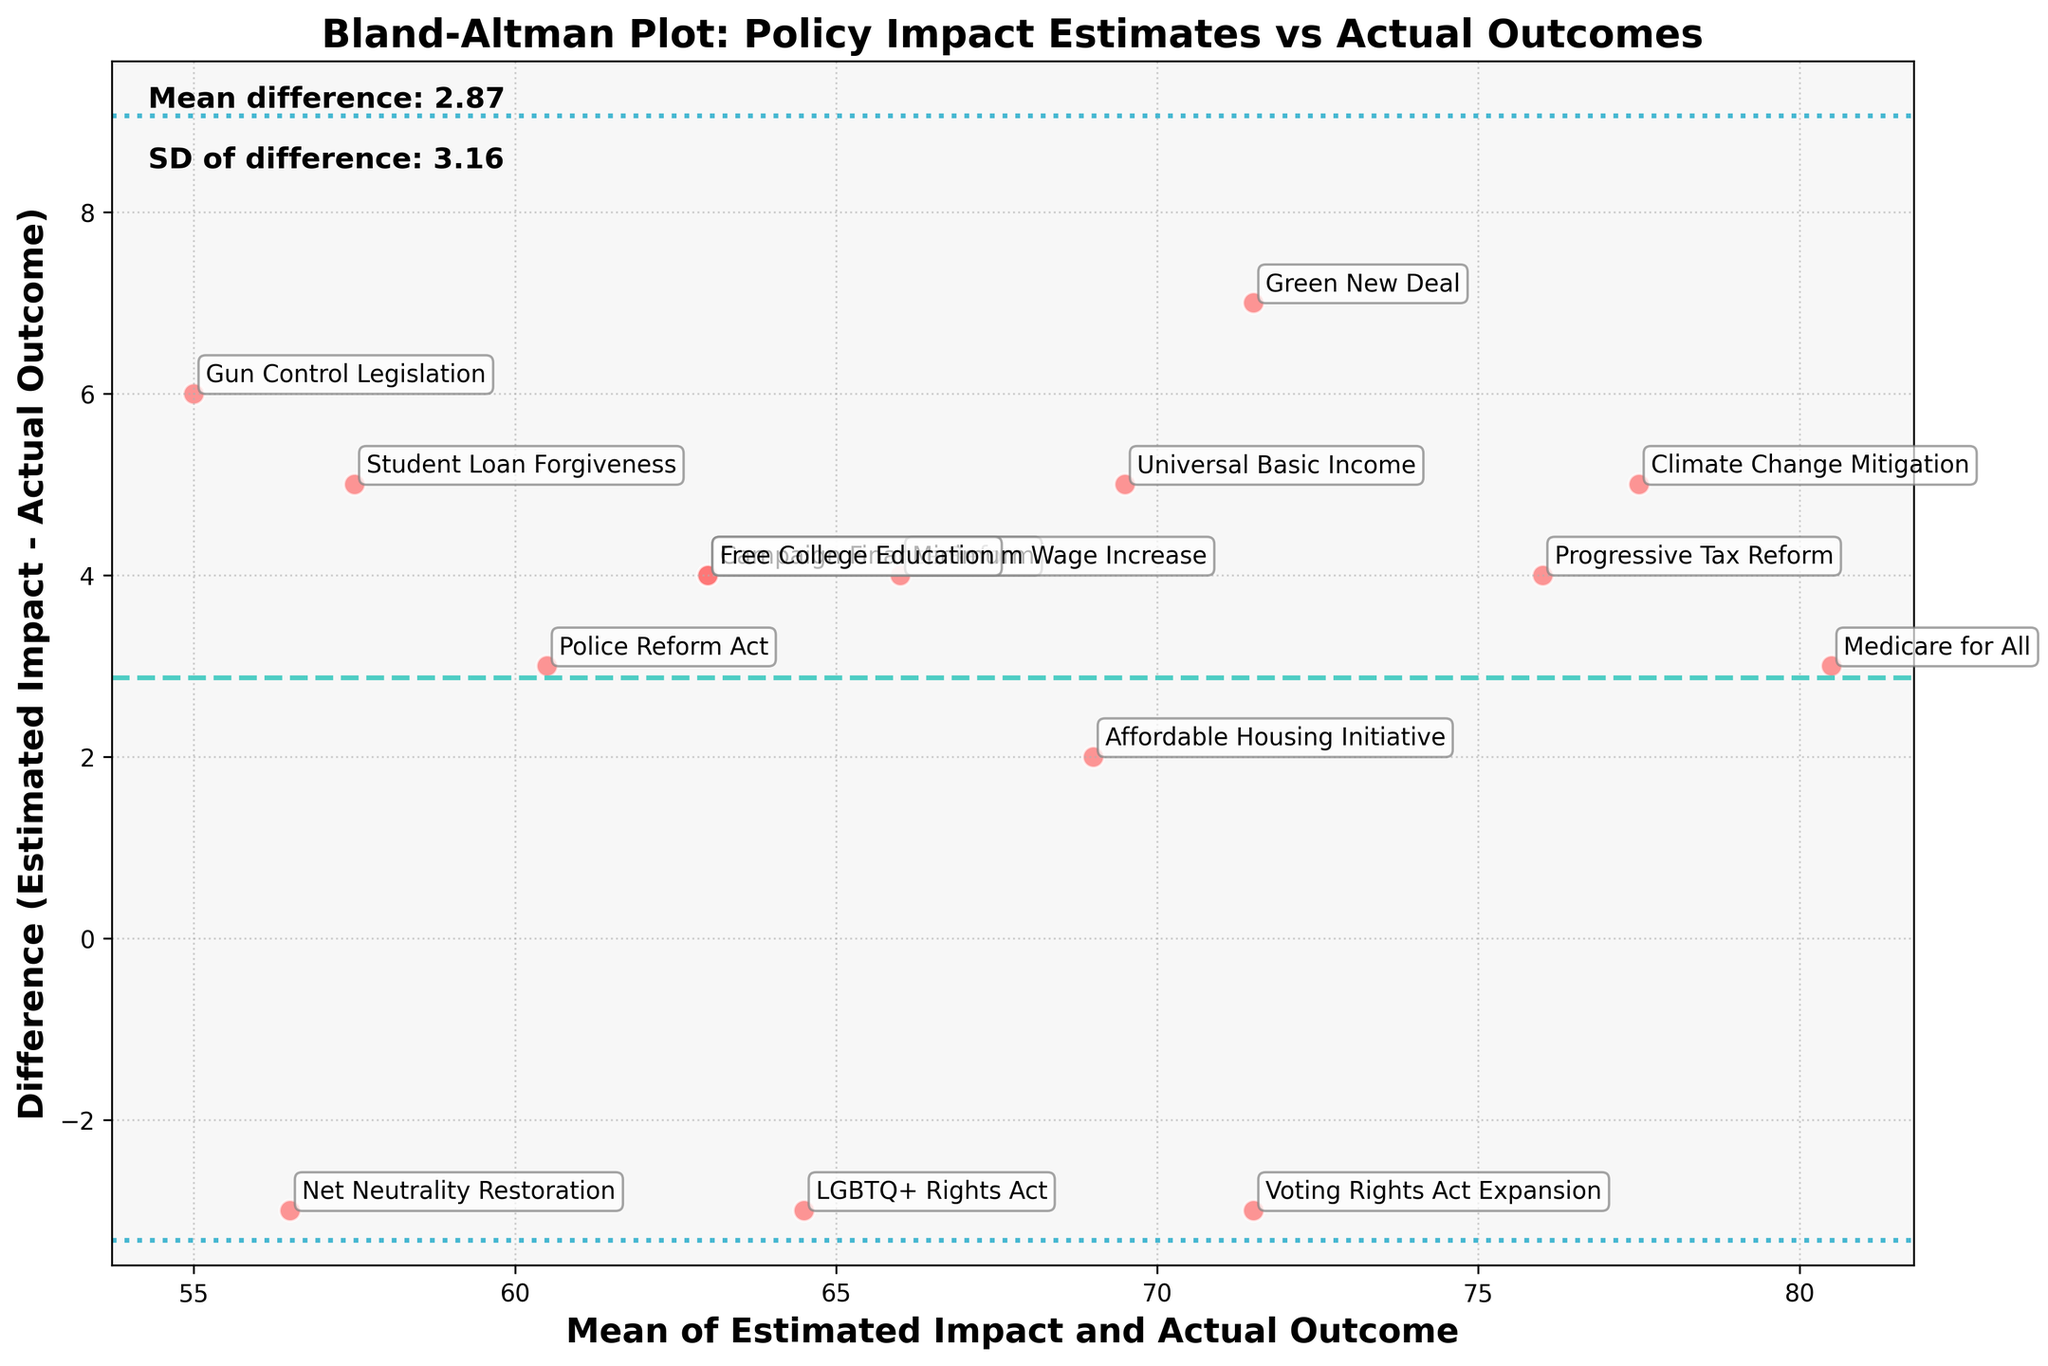What is the title of the plot? The title is usually found at the top of the plot. In this case, it should be stated in clear, bold text.
Answer: Bland-Altman Plot: Policy Impact Estimates vs Actual Outcomes How many data points are plotted in this Bland-Altman plot? Each policy represents one data point plotted on the Bland-Altman plot. Count the total number of policies listed.
Answer: 15 What do the horizontal dashed lines represent in the plot? These lines typically represent key statistical values in a Bland-Altman plot. The middle dashed line represents the mean difference, while the lines above and below represent the mean difference plus/minus 1.96 times the standard deviation, respectively.
Answer: They represent the mean difference and ±1.96 times the standard deviation Which policy shows the largest positive difference between estimated impact and actual outcome? To determine this, we need to look for the highest data point on the y-axis in the plot, which represents the difference (Estimated Impact - Actual Outcome).
Answer: Medicare for All Which policy is closest to the mean difference line? To answer this, find the data point that lies closest to the middle dashed line across the plot.
Answer: Affordable Housing Initiative What is the mean difference between the estimated impacts and the actual outcomes? The plot displays the mean difference explicitly in the text annotations typically found on the graph. In this plot, we look at the labeled mean difference.
Answer: 2.60 What is the standard deviation of the differences? Like the mean difference, the standard deviation of the differences is annotated on the plot. Look for the labeled standard deviation in the annotations.
Answer: 6.66 How does the impact estimate for the 'Voting Rights Act Expansion' compare to its actual outcome? Identify the specific data point for 'Voting Rights Act Expansion' and observe its position relative to the horizontal zero line in the plot. If it's above the line, the estimate is higher; if below, lower.
Answer: The actual outcome is higher Which policy has an actual outcome higher than its estimated impact? Look for any data points that lie below the horizontal zero line. These indicate where actual outcomes exceed estimated impacts.
Answer: Voting Rights Act Expansion What can we infer from the plot about the accuracy of policy impact estimates? Review the overall spread of the data points, their average differences, and standard deviation to determine if these estimates are consistently over or underestimating the actual impacts.
Answer: Policy impact estimates are generally close to actual outcomes but vary slightly, as indicated by a mean difference close to zero and visible spread 